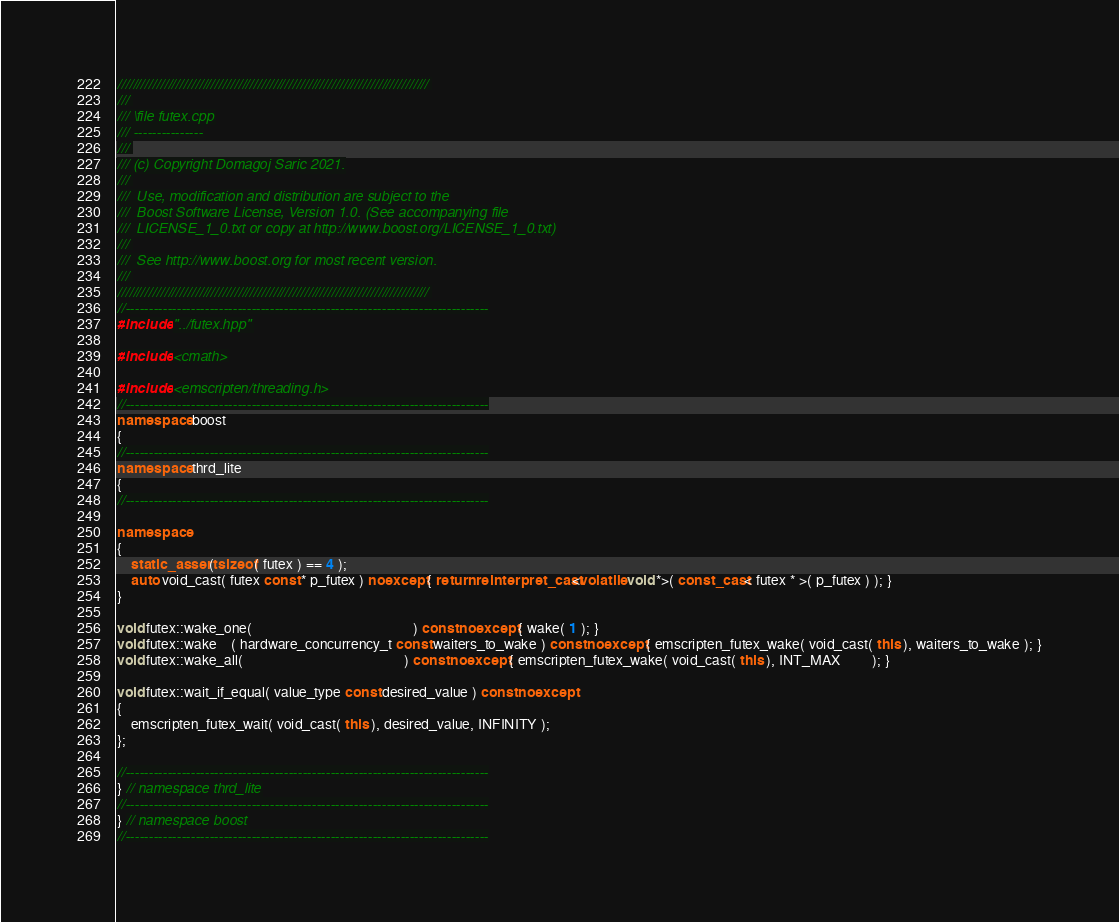<code> <loc_0><loc_0><loc_500><loc_500><_C++_>////////////////////////////////////////////////////////////////////////////////
///
/// \file futex.cpp
/// ---------------
///
/// (c) Copyright Domagoj Saric 2021.
///
///  Use, modification and distribution are subject to the
///  Boost Software License, Version 1.0. (See accompanying file
///  LICENSE_1_0.txt or copy at http://www.boost.org/LICENSE_1_0.txt)
///
///  See http://www.boost.org for most recent version.
///
////////////////////////////////////////////////////////////////////////////////
//------------------------------------------------------------------------------
#include "../futex.hpp"

#include <cmath>

#include <emscripten/threading.h>
//------------------------------------------------------------------------------
namespace boost
{
//------------------------------------------------------------------------------
namespace thrd_lite
{
//------------------------------------------------------------------------------

namespace
{
    static_assert( sizeof( futex ) == 4 );
    auto void_cast( futex const * p_futex ) noexcept { return reinterpret_cast<volatile void *>( const_cast< futex * >( p_futex ) ); }
}

void futex::wake_one(                                              ) const noexcept { wake( 1 ); }
void futex::wake    ( hardware_concurrency_t const waiters_to_wake ) const noexcept { emscripten_futex_wake( void_cast( this ), waiters_to_wake ); }
void futex::wake_all(                                              ) const noexcept { emscripten_futex_wake( void_cast( this ), INT_MAX         ); }

void futex::wait_if_equal( value_type const desired_value ) const noexcept
{
    emscripten_futex_wait( void_cast( this ), desired_value, INFINITY );
};

//------------------------------------------------------------------------------
} // namespace thrd_lite
//------------------------------------------------------------------------------
} // namespace boost
//------------------------------------------------------------------------------
</code> 